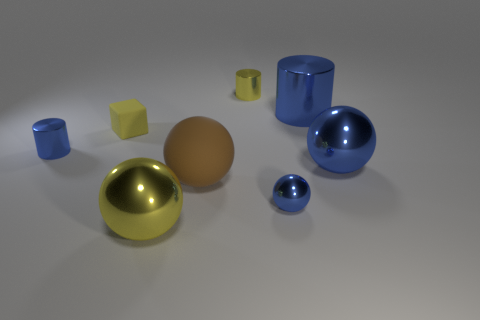How many cylinders are either tiny matte objects or small blue metal objects?
Offer a very short reply. 1. There is a sphere that is the same material as the yellow cube; what color is it?
Your response must be concise. Brown. Is the number of large metal spheres less than the number of small gray rubber cylinders?
Keep it short and to the point. No. Does the blue metal thing that is to the left of the tiny rubber cube have the same shape as the yellow shiny object that is behind the tiny matte cube?
Offer a terse response. Yes. How many things are either metal things or large cylinders?
Give a very brief answer. 6. There is a sphere that is the same size as the yellow cube; what is its color?
Make the answer very short. Blue. What number of rubber cubes are behind the tiny thing left of the tiny yellow matte object?
Offer a very short reply. 1. How many metal objects are both on the left side of the small yellow cube and in front of the small blue metallic ball?
Keep it short and to the point. 0. How many objects are blue objects on the right side of the small yellow metal thing or objects that are left of the matte block?
Provide a short and direct response. 4. What number of other things are there of the same size as the yellow ball?
Your answer should be compact. 3. 